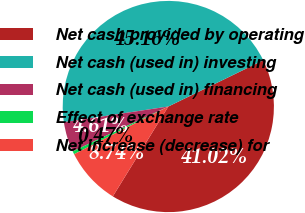<chart> <loc_0><loc_0><loc_500><loc_500><pie_chart><fcel>Net cash provided by operating<fcel>Net cash (used in) investing<fcel>Net cash (used in) financing<fcel>Effect of exchange rate<fcel>Net increase (decrease) for<nl><fcel>41.02%<fcel>45.16%<fcel>4.61%<fcel>0.47%<fcel>8.74%<nl></chart> 